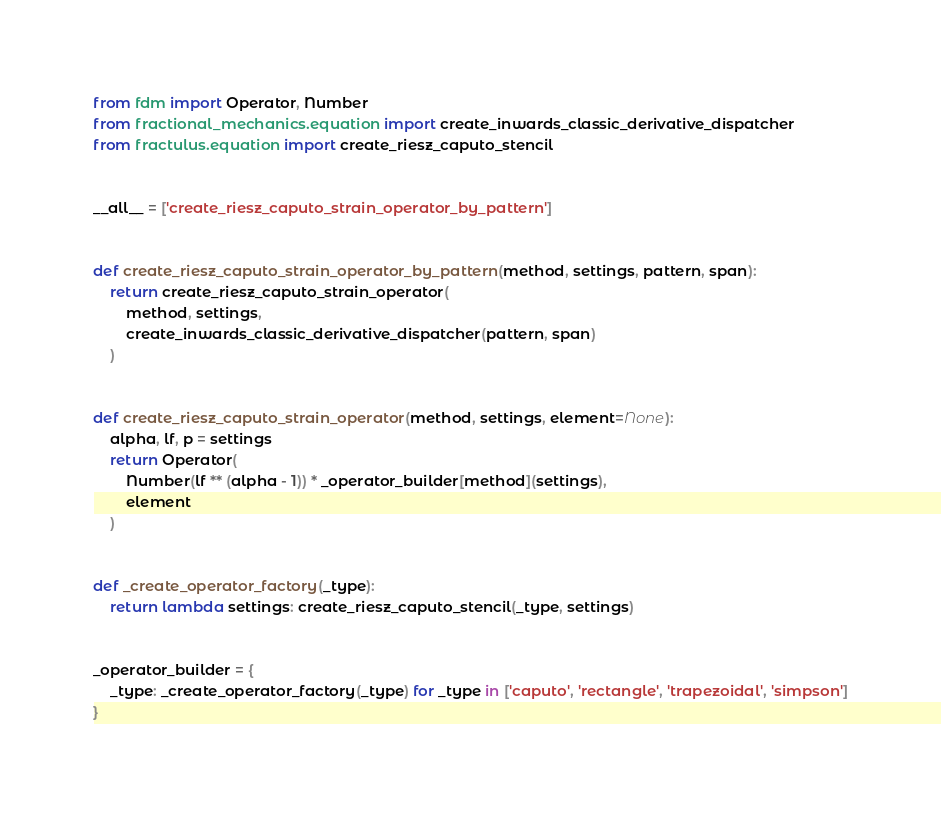Convert code to text. <code><loc_0><loc_0><loc_500><loc_500><_Python_>from fdm import Operator, Number
from fractional_mechanics.equation import create_inwards_classic_derivative_dispatcher
from fractulus.equation import create_riesz_caputo_stencil


__all__ = ['create_riesz_caputo_strain_operator_by_pattern']


def create_riesz_caputo_strain_operator_by_pattern(method, settings, pattern, span):
    return create_riesz_caputo_strain_operator(
        method, settings,
        create_inwards_classic_derivative_dispatcher(pattern, span)
    )


def create_riesz_caputo_strain_operator(method, settings, element=None):
    alpha, lf, p = settings
    return Operator(
        Number(lf ** (alpha - 1)) * _operator_builder[method](settings),
        element
    )


def _create_operator_factory(_type):
    return lambda settings: create_riesz_caputo_stencil(_type, settings)


_operator_builder = {
    _type: _create_operator_factory(_type) for _type in ['caputo', 'rectangle', 'trapezoidal', 'simpson']
}


</code> 